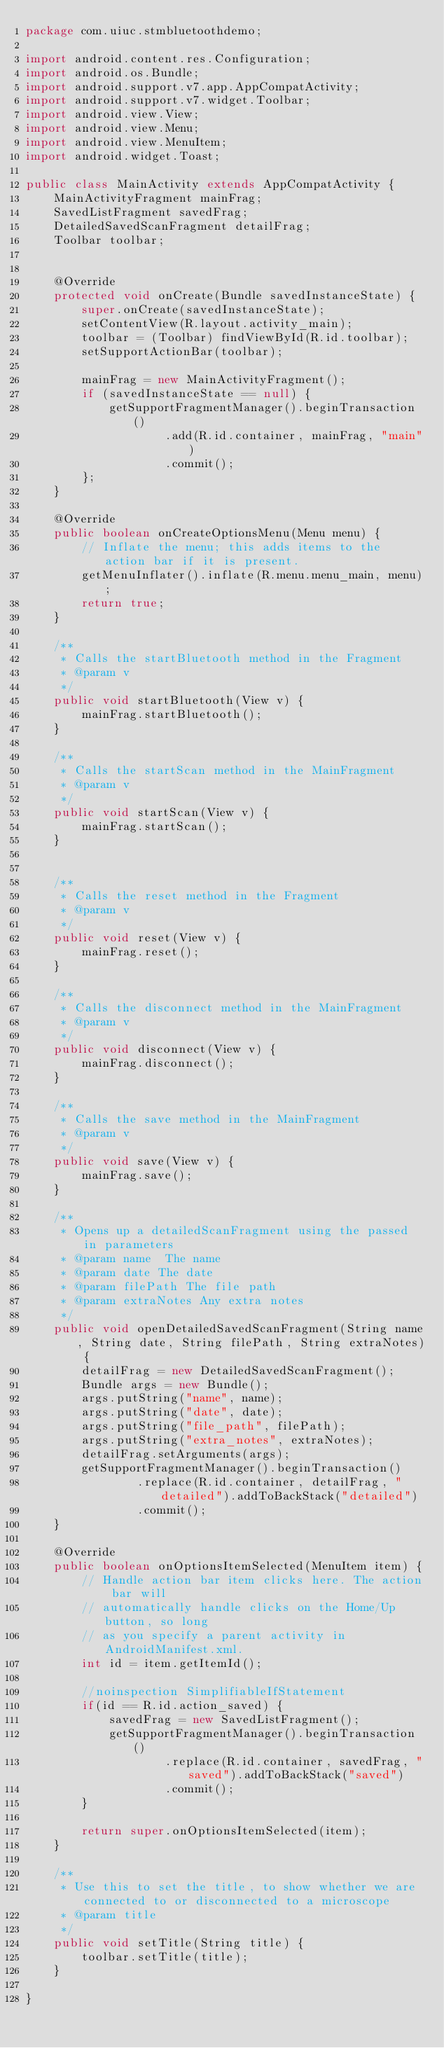Convert code to text. <code><loc_0><loc_0><loc_500><loc_500><_Java_>package com.uiuc.stmbluetoothdemo;

import android.content.res.Configuration;
import android.os.Bundle;
import android.support.v7.app.AppCompatActivity;
import android.support.v7.widget.Toolbar;
import android.view.View;
import android.view.Menu;
import android.view.MenuItem;
import android.widget.Toast;

public class MainActivity extends AppCompatActivity {
    MainActivityFragment mainFrag;
    SavedListFragment savedFrag;
    DetailedSavedScanFragment detailFrag;
    Toolbar toolbar;


    @Override
    protected void onCreate(Bundle savedInstanceState) {
        super.onCreate(savedInstanceState);
        setContentView(R.layout.activity_main);
        toolbar = (Toolbar) findViewById(R.id.toolbar);
        setSupportActionBar(toolbar);

        mainFrag = new MainActivityFragment();
        if (savedInstanceState == null) {
            getSupportFragmentManager().beginTransaction()
                    .add(R.id.container, mainFrag, "main")
                    .commit();
        };
    }

    @Override
    public boolean onCreateOptionsMenu(Menu menu) {
        // Inflate the menu; this adds items to the action bar if it is present.
        getMenuInflater().inflate(R.menu.menu_main, menu);
        return true;
    }

    /**
     * Calls the startBluetooth method in the Fragment
     * @param v
     */
    public void startBluetooth(View v) {
        mainFrag.startBluetooth();
    }

    /**
     * Calls the startScan method in the MainFragment
     * @param v
     */
    public void startScan(View v) {
        mainFrag.startScan();
    }


    /**
     * Calls the reset method in the Fragment
     * @param v
     */
    public void reset(View v) {
        mainFrag.reset();
    }

    /**
     * Calls the disconnect method in the MainFragment
     * @param v
     */
    public void disconnect(View v) {
        mainFrag.disconnect();
    }

    /**
     * Calls the save method in the MainFragment
     * @param v
     */
    public void save(View v) {
        mainFrag.save();
    }

    /**
     * Opens up a detailedScanFragment using the passed in parameters
     * @param name  The name
     * @param date The date
     * @param filePath The file path
     * @param extraNotes Any extra notes
     */
    public void openDetailedSavedScanFragment(String name, String date, String filePath, String extraNotes) {
        detailFrag = new DetailedSavedScanFragment();
        Bundle args = new Bundle();
        args.putString("name", name);
        args.putString("date", date);
        args.putString("file_path", filePath);
        args.putString("extra_notes", extraNotes);
        detailFrag.setArguments(args);
        getSupportFragmentManager().beginTransaction()
                .replace(R.id.container, detailFrag, "detailed").addToBackStack("detailed")
                .commit();
    }

    @Override
    public boolean onOptionsItemSelected(MenuItem item) {
        // Handle action bar item clicks here. The action bar will
        // automatically handle clicks on the Home/Up button, so long
        // as you specify a parent activity in AndroidManifest.xml.
        int id = item.getItemId();

        //noinspection SimplifiableIfStatement
        if(id == R.id.action_saved) {
            savedFrag = new SavedListFragment();
            getSupportFragmentManager().beginTransaction()
                    .replace(R.id.container, savedFrag, "saved").addToBackStack("saved")
                    .commit();
        }

        return super.onOptionsItemSelected(item);
    }

    /**
     * Use this to set the title, to show whether we are connected to or disconnected to a microscope
     * @param title
     */
    public void setTitle(String title) {
        toolbar.setTitle(title);
    }

}
</code> 